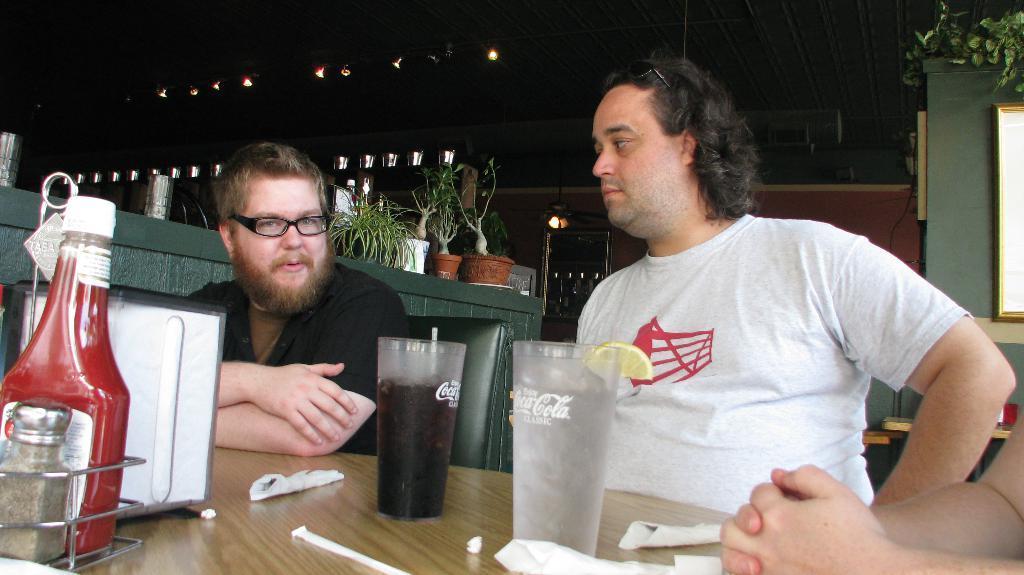Describe this image in one or two sentences. In this image there are people sitting behind the table. There is bottle, glasses, papers, on the table. At the back there are house plants on the table. At the top there are lights. 